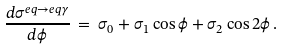<formula> <loc_0><loc_0><loc_500><loc_500>\frac { d \sigma ^ { e q \rightarrow e q \gamma } } { d \phi } \, = \, \sigma _ { 0 } + \sigma _ { 1 } \cos \phi + \sigma _ { 2 } \cos 2 \phi \, .</formula> 